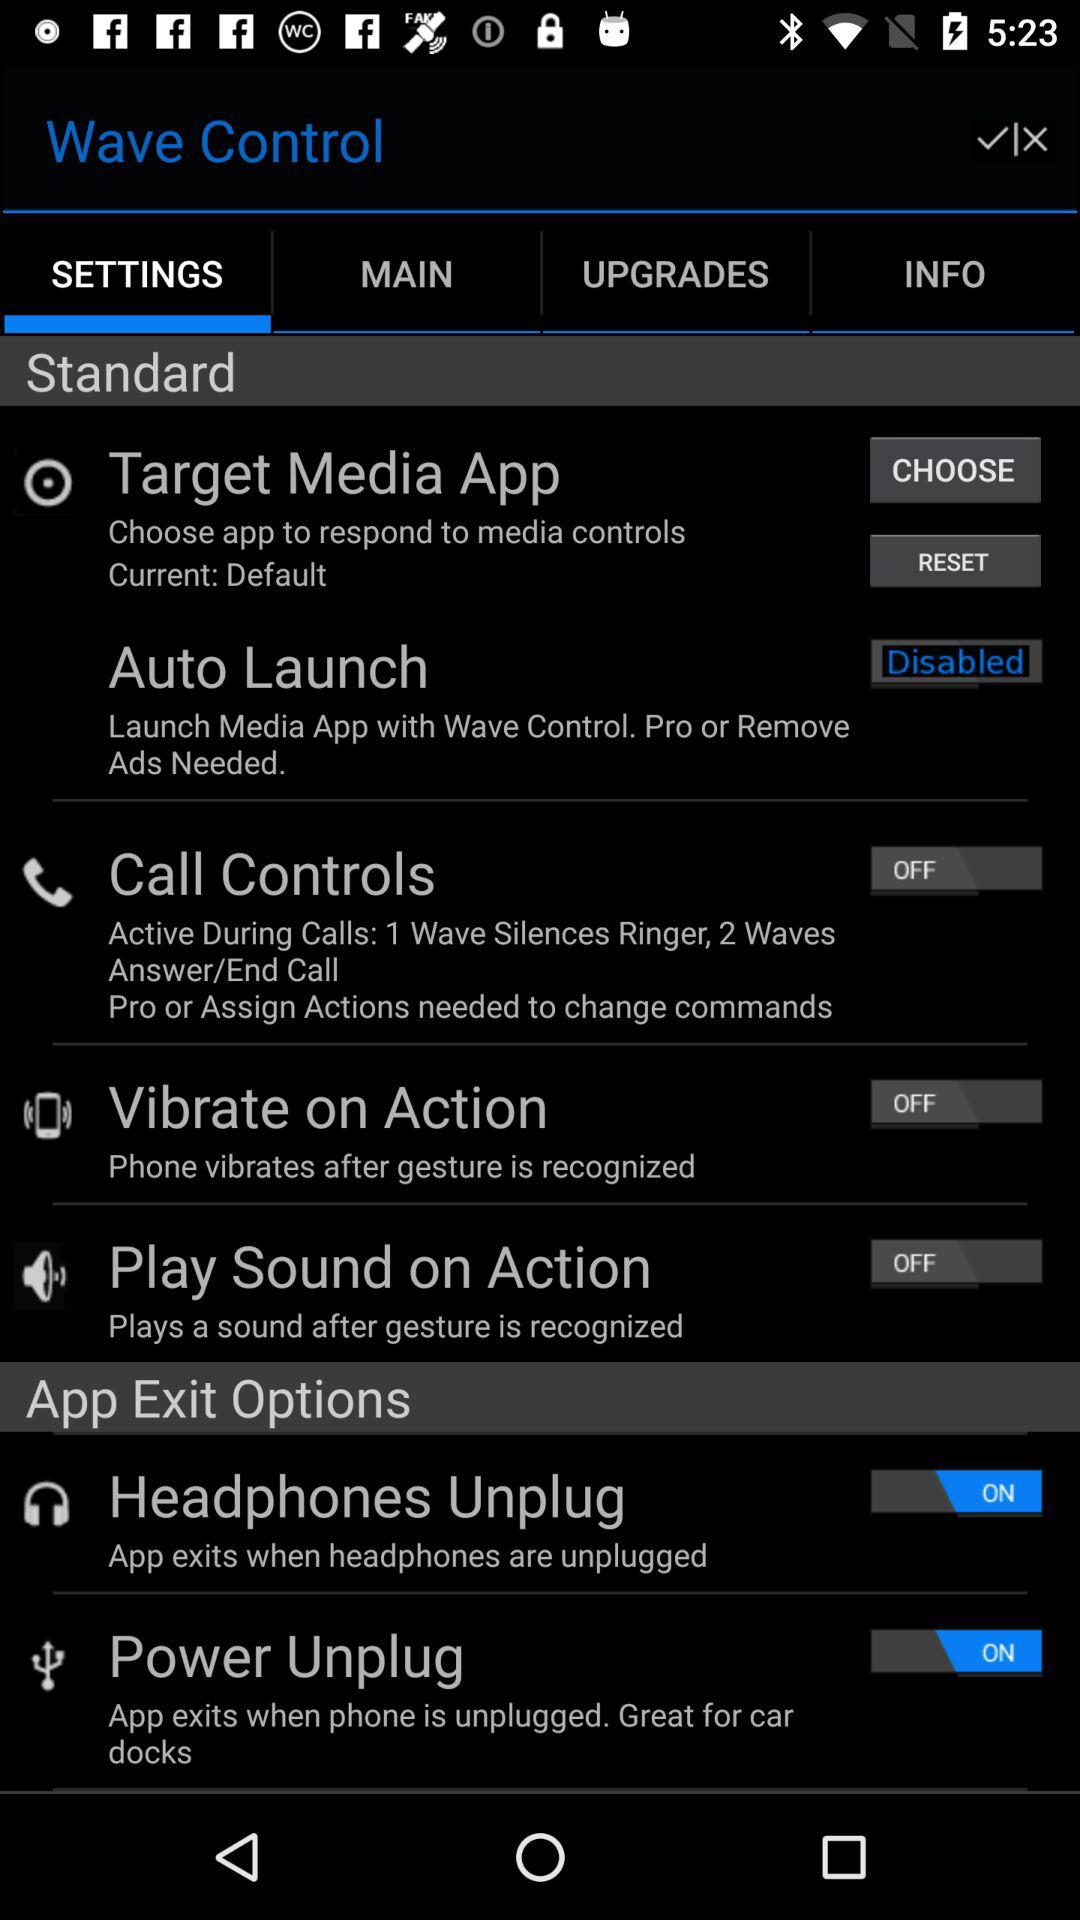What is the status of the auto-launch? The status of the auto-launch is disabled. 